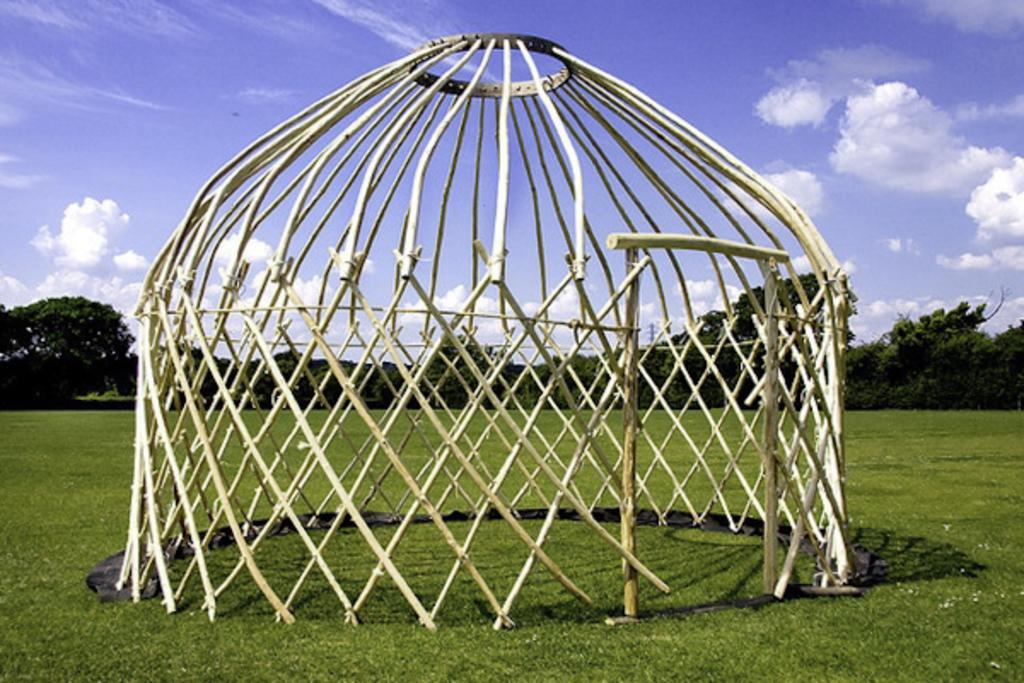What is the weather like in the image? The sky is cloudy in the image. What type of vegetation covers the land in the image? The land is covered with grass in the image. What can be seen in the background of the image? There are trees in the background of the image. What type of structure is being built in the image? There is an under-construction house in the image. How many trucks are parked near the under-construction house in the image? There are no trucks present in the image; it only shows an under-construction house, grass, trees, and a cloudy sky. 